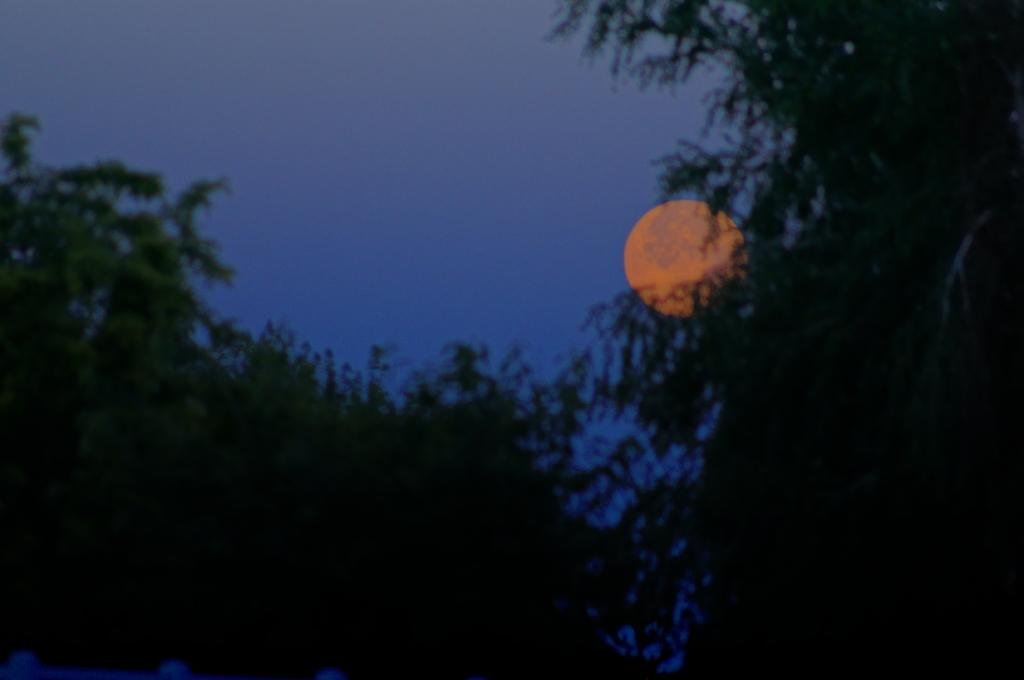What time of day was the image taken? The image was taken at night. What can be seen in the foreground of the image? There are trees in the foreground of the image. What is visible in the background of the image? The sky is visible in the background of the image. What can be seen in the center of the sky? There is a celestial body in the center of the sky. What type of clover is growing near the trees in the image? There is no clover visible in the image; it only features trees in the foreground. Can you hear the sound of a drum in the image? There is no sound present in the image, so it is not possible to hear a drum. 